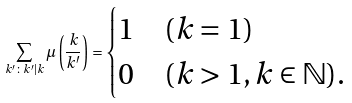<formula> <loc_0><loc_0><loc_500><loc_500>\sum _ { k ^ { \prime } \colon k ^ { \prime } | k } \mu \left ( \frac { k } { k ^ { \prime } } \right ) = \begin{cases} 1 & ( k = 1 ) \\ 0 & ( k > 1 , k \in \mathbb { N } ) . \end{cases}</formula> 